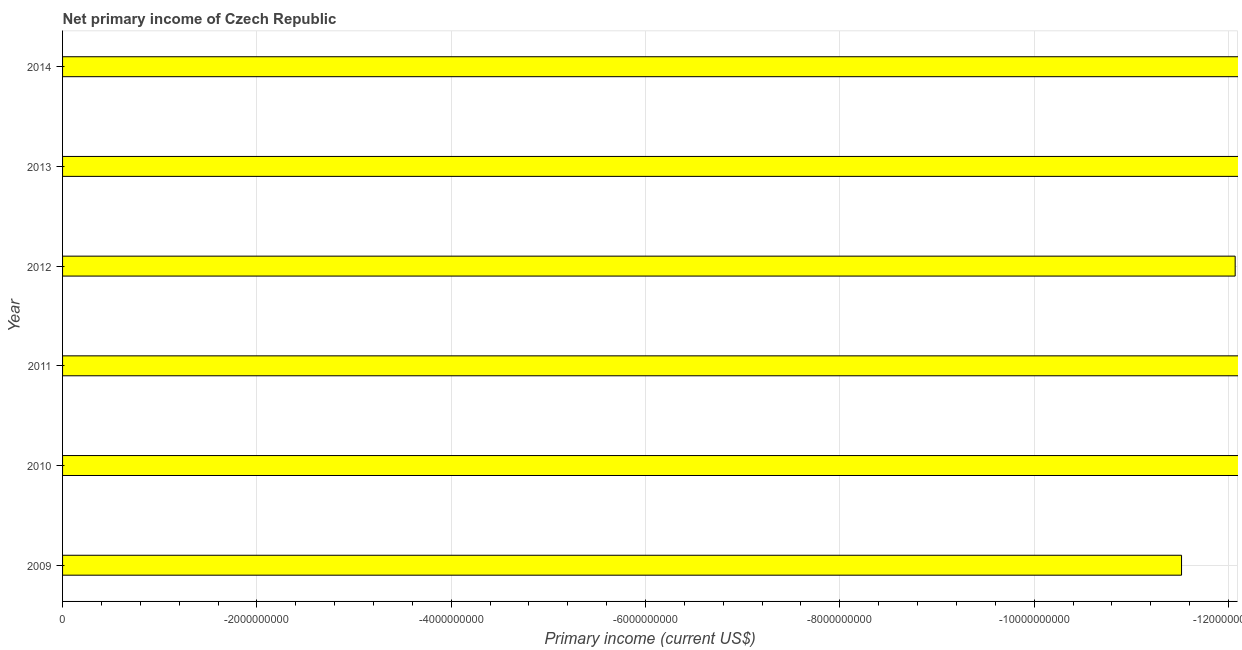Does the graph contain any zero values?
Give a very brief answer. Yes. What is the title of the graph?
Offer a terse response. Net primary income of Czech Republic. What is the label or title of the X-axis?
Offer a terse response. Primary income (current US$). What is the label or title of the Y-axis?
Make the answer very short. Year. What is the amount of primary income in 2009?
Offer a very short reply. 0. Across all years, what is the minimum amount of primary income?
Offer a very short reply. 0. What is the average amount of primary income per year?
Provide a succinct answer. 0. In how many years, is the amount of primary income greater than -6800000000 US$?
Keep it short and to the point. 0. In how many years, is the amount of primary income greater than the average amount of primary income taken over all years?
Keep it short and to the point. 0. How many years are there in the graph?
Your answer should be very brief. 6. Are the values on the major ticks of X-axis written in scientific E-notation?
Offer a very short reply. No. What is the Primary income (current US$) of 2009?
Make the answer very short. 0. What is the Primary income (current US$) in 2011?
Your response must be concise. 0. What is the Primary income (current US$) in 2012?
Provide a short and direct response. 0. What is the Primary income (current US$) of 2013?
Make the answer very short. 0. 